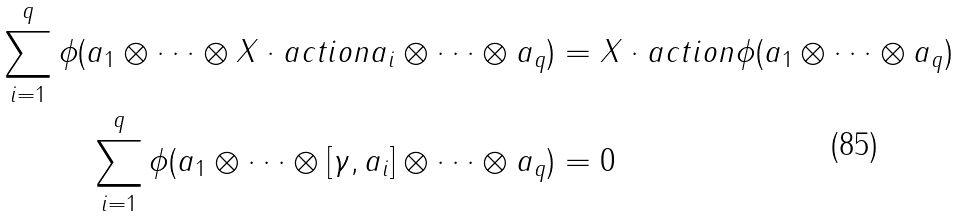<formula> <loc_0><loc_0><loc_500><loc_500>\sum _ { i = 1 } ^ { q } \phi ( a _ { 1 } \otimes \cdots \otimes X \cdot a c t i o n a _ { i } \otimes \cdots \otimes a _ { q } ) & = X \cdot a c t i o n \phi ( a _ { 1 } \otimes \cdots \otimes a _ { q } ) \\ \sum _ { i = 1 } ^ { q } \phi ( a _ { 1 } \otimes \cdots \otimes [ \gamma , a _ { i } ] \otimes \cdots \otimes a _ { q } ) & = 0</formula> 